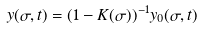<formula> <loc_0><loc_0><loc_500><loc_500>y ( \sigma , t ) = ( 1 - K ( \sigma ) ) ^ { - 1 } y _ { 0 } ( \sigma , t )</formula> 